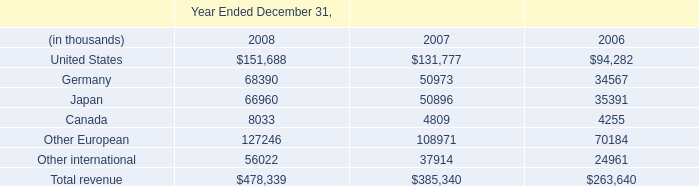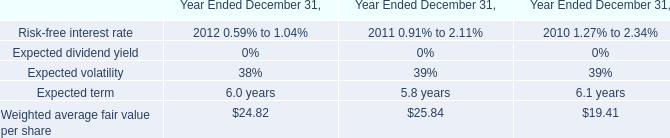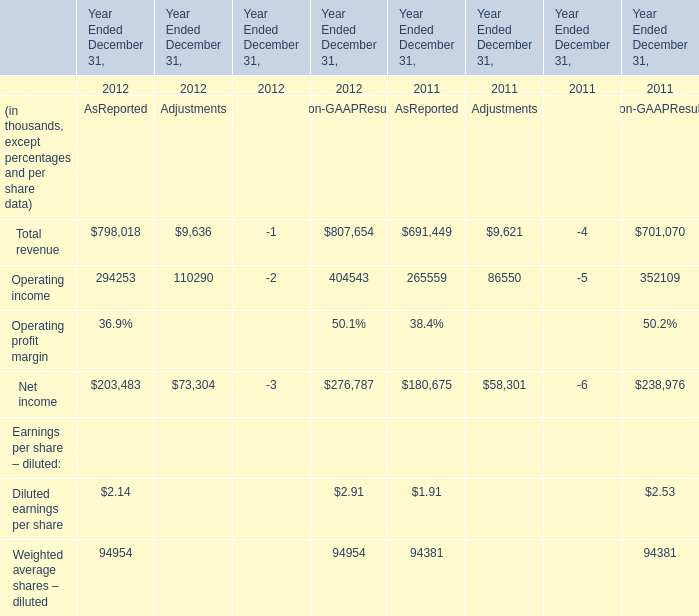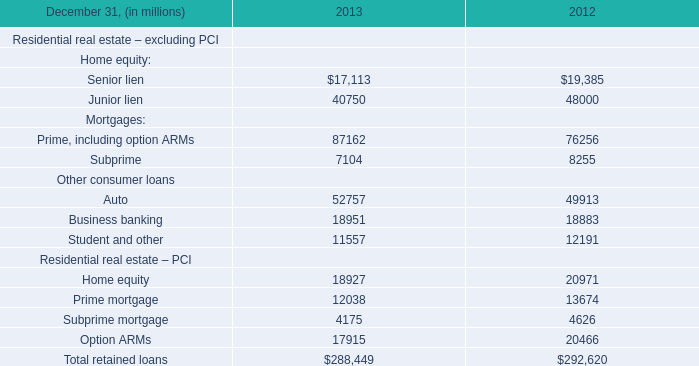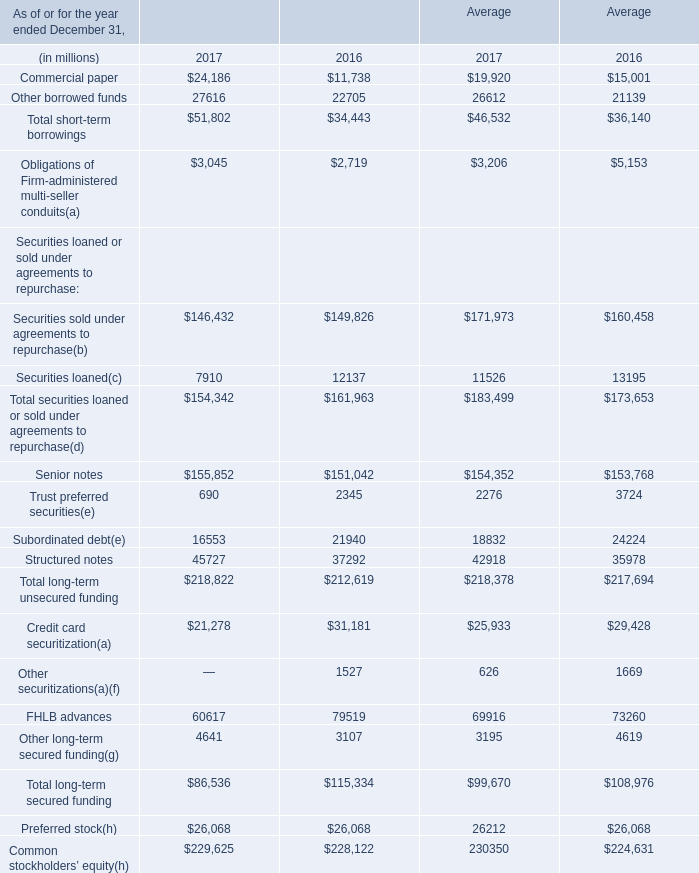what is the total combined royalty fees for years ended 2006-2008 , in millions? 
Computations: ((6.3 + 5.2) + 3.9)
Answer: 15.4. 